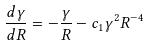Convert formula to latex. <formula><loc_0><loc_0><loc_500><loc_500>\frac { d \gamma } { d R } = - \frac { \gamma } { R } - c _ { 1 } \gamma ^ { 2 } R ^ { - 4 }</formula> 